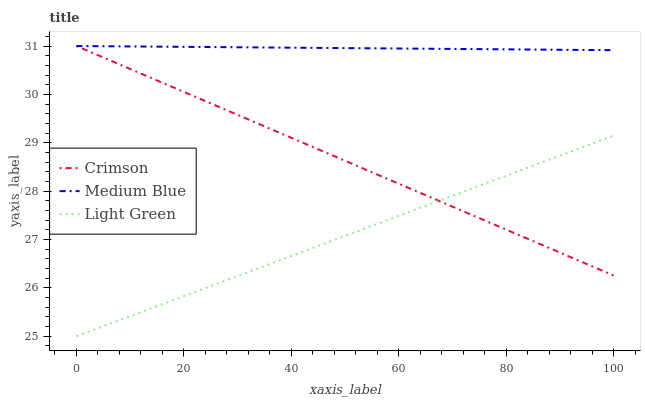Does Medium Blue have the minimum area under the curve?
Answer yes or no. No. Does Light Green have the maximum area under the curve?
Answer yes or no. No. Is Light Green the smoothest?
Answer yes or no. No. Is Medium Blue the roughest?
Answer yes or no. No. Does Medium Blue have the lowest value?
Answer yes or no. No. Does Light Green have the highest value?
Answer yes or no. No. Is Light Green less than Medium Blue?
Answer yes or no. Yes. Is Medium Blue greater than Light Green?
Answer yes or no. Yes. Does Light Green intersect Medium Blue?
Answer yes or no. No. 